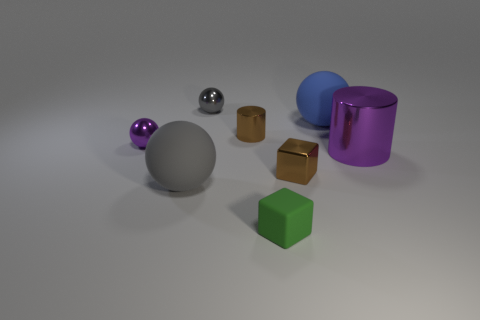There is a blue rubber sphere; how many large blue spheres are in front of it? Based on the image provided, there are no large blue spheres in front of the blue rubber sphere. The blue sphere in the image is the only one of its color and size, positioned in clear view with several other objects of various colors and shapes surrounding it. 